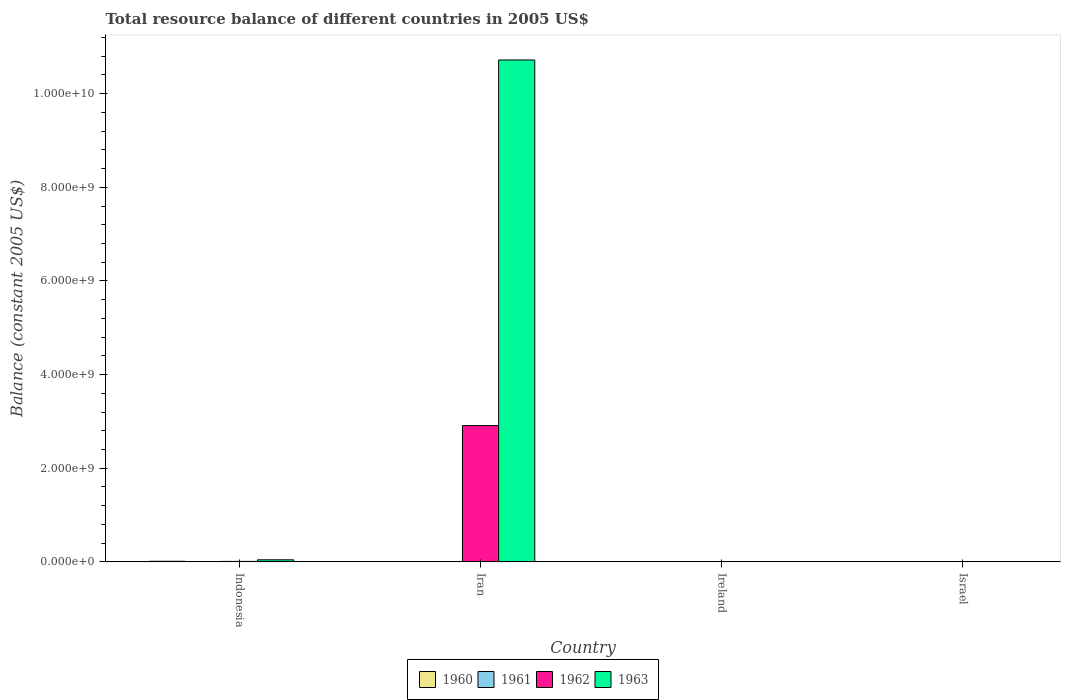Are the number of bars on each tick of the X-axis equal?
Your response must be concise. No. How many bars are there on the 4th tick from the right?
Keep it short and to the point. 3. In how many cases, is the number of bars for a given country not equal to the number of legend labels?
Provide a succinct answer. 3. What is the total resource balance in 1962 in Indonesia?
Your answer should be compact. 9.90e+06. Across all countries, what is the maximum total resource balance in 1963?
Your response must be concise. 1.07e+1. What is the total total resource balance in 1962 in the graph?
Offer a terse response. 2.92e+09. What is the difference between the total resource balance in 1962 in Iran and that in Israel?
Provide a succinct answer. 2.91e+09. What is the difference between the total resource balance in 1961 in Indonesia and the total resource balance in 1962 in Iran?
Your response must be concise. -2.91e+09. What is the average total resource balance in 1963 per country?
Keep it short and to the point. 2.69e+09. What is the difference between the total resource balance of/in 1963 and total resource balance of/in 1960 in Israel?
Ensure brevity in your answer.  1.96e+04. In how many countries, is the total resource balance in 1961 greater than 6400000000 US$?
Provide a short and direct response. 0. What is the ratio of the total resource balance in 1963 in Iran to that in Israel?
Your answer should be very brief. 4.52e+05. Is the total resource balance in 1962 in Indonesia less than that in Iran?
Make the answer very short. Yes. What is the difference between the highest and the second highest total resource balance in 1963?
Keep it short and to the point. -4.42e+07. What is the difference between the highest and the lowest total resource balance in 1962?
Ensure brevity in your answer.  2.91e+09. Is it the case that in every country, the sum of the total resource balance in 1963 and total resource balance in 1961 is greater than the sum of total resource balance in 1960 and total resource balance in 1962?
Give a very brief answer. No. Is it the case that in every country, the sum of the total resource balance in 1961 and total resource balance in 1963 is greater than the total resource balance in 1962?
Keep it short and to the point. No. Are the values on the major ticks of Y-axis written in scientific E-notation?
Your answer should be very brief. Yes. Does the graph contain grids?
Offer a terse response. No. Where does the legend appear in the graph?
Give a very brief answer. Bottom center. What is the title of the graph?
Give a very brief answer. Total resource balance of different countries in 2005 US$. What is the label or title of the X-axis?
Give a very brief answer. Country. What is the label or title of the Y-axis?
Your answer should be compact. Balance (constant 2005 US$). What is the Balance (constant 2005 US$) in 1960 in Indonesia?
Give a very brief answer. 1.30e+07. What is the Balance (constant 2005 US$) of 1962 in Indonesia?
Offer a very short reply. 9.90e+06. What is the Balance (constant 2005 US$) of 1963 in Indonesia?
Your answer should be very brief. 4.42e+07. What is the Balance (constant 2005 US$) in 1961 in Iran?
Offer a terse response. 0. What is the Balance (constant 2005 US$) of 1962 in Iran?
Ensure brevity in your answer.  2.91e+09. What is the Balance (constant 2005 US$) in 1963 in Iran?
Provide a succinct answer. 1.07e+1. What is the Balance (constant 2005 US$) in 1961 in Ireland?
Offer a terse response. 0. What is the Balance (constant 2005 US$) in 1963 in Ireland?
Make the answer very short. 0. What is the Balance (constant 2005 US$) in 1960 in Israel?
Your answer should be compact. 4100. What is the Balance (constant 2005 US$) of 1961 in Israel?
Offer a very short reply. 2000. What is the Balance (constant 2005 US$) in 1962 in Israel?
Your answer should be very brief. 8000. What is the Balance (constant 2005 US$) of 1963 in Israel?
Provide a succinct answer. 2.37e+04. Across all countries, what is the maximum Balance (constant 2005 US$) of 1960?
Your answer should be compact. 1.30e+07. Across all countries, what is the maximum Balance (constant 2005 US$) of 1962?
Ensure brevity in your answer.  2.91e+09. Across all countries, what is the maximum Balance (constant 2005 US$) in 1963?
Make the answer very short. 1.07e+1. What is the total Balance (constant 2005 US$) of 1960 in the graph?
Your answer should be very brief. 1.30e+07. What is the total Balance (constant 2005 US$) in 1961 in the graph?
Your answer should be very brief. 2000. What is the total Balance (constant 2005 US$) in 1962 in the graph?
Your answer should be compact. 2.92e+09. What is the total Balance (constant 2005 US$) of 1963 in the graph?
Your answer should be very brief. 1.08e+1. What is the difference between the Balance (constant 2005 US$) of 1962 in Indonesia and that in Iran?
Offer a very short reply. -2.90e+09. What is the difference between the Balance (constant 2005 US$) in 1963 in Indonesia and that in Iran?
Ensure brevity in your answer.  -1.07e+1. What is the difference between the Balance (constant 2005 US$) of 1960 in Indonesia and that in Israel?
Make the answer very short. 1.30e+07. What is the difference between the Balance (constant 2005 US$) of 1962 in Indonesia and that in Israel?
Offer a terse response. 9.90e+06. What is the difference between the Balance (constant 2005 US$) in 1963 in Indonesia and that in Israel?
Ensure brevity in your answer.  4.42e+07. What is the difference between the Balance (constant 2005 US$) in 1962 in Iran and that in Israel?
Keep it short and to the point. 2.91e+09. What is the difference between the Balance (constant 2005 US$) of 1963 in Iran and that in Israel?
Your response must be concise. 1.07e+1. What is the difference between the Balance (constant 2005 US$) of 1960 in Indonesia and the Balance (constant 2005 US$) of 1962 in Iran?
Your answer should be very brief. -2.90e+09. What is the difference between the Balance (constant 2005 US$) in 1960 in Indonesia and the Balance (constant 2005 US$) in 1963 in Iran?
Ensure brevity in your answer.  -1.07e+1. What is the difference between the Balance (constant 2005 US$) of 1962 in Indonesia and the Balance (constant 2005 US$) of 1963 in Iran?
Provide a succinct answer. -1.07e+1. What is the difference between the Balance (constant 2005 US$) of 1960 in Indonesia and the Balance (constant 2005 US$) of 1961 in Israel?
Give a very brief answer. 1.30e+07. What is the difference between the Balance (constant 2005 US$) of 1960 in Indonesia and the Balance (constant 2005 US$) of 1962 in Israel?
Provide a succinct answer. 1.30e+07. What is the difference between the Balance (constant 2005 US$) in 1960 in Indonesia and the Balance (constant 2005 US$) in 1963 in Israel?
Offer a very short reply. 1.30e+07. What is the difference between the Balance (constant 2005 US$) in 1962 in Indonesia and the Balance (constant 2005 US$) in 1963 in Israel?
Your answer should be very brief. 9.88e+06. What is the difference between the Balance (constant 2005 US$) in 1962 in Iran and the Balance (constant 2005 US$) in 1963 in Israel?
Make the answer very short. 2.91e+09. What is the average Balance (constant 2005 US$) of 1960 per country?
Give a very brief answer. 3.25e+06. What is the average Balance (constant 2005 US$) of 1962 per country?
Your answer should be very brief. 7.30e+08. What is the average Balance (constant 2005 US$) of 1963 per country?
Offer a very short reply. 2.69e+09. What is the difference between the Balance (constant 2005 US$) in 1960 and Balance (constant 2005 US$) in 1962 in Indonesia?
Offer a very short reply. 3.08e+06. What is the difference between the Balance (constant 2005 US$) of 1960 and Balance (constant 2005 US$) of 1963 in Indonesia?
Your response must be concise. -3.12e+07. What is the difference between the Balance (constant 2005 US$) in 1962 and Balance (constant 2005 US$) in 1963 in Indonesia?
Offer a very short reply. -3.43e+07. What is the difference between the Balance (constant 2005 US$) of 1962 and Balance (constant 2005 US$) of 1963 in Iran?
Offer a terse response. -7.81e+09. What is the difference between the Balance (constant 2005 US$) in 1960 and Balance (constant 2005 US$) in 1961 in Israel?
Provide a short and direct response. 2100. What is the difference between the Balance (constant 2005 US$) in 1960 and Balance (constant 2005 US$) in 1962 in Israel?
Your answer should be very brief. -3900. What is the difference between the Balance (constant 2005 US$) in 1960 and Balance (constant 2005 US$) in 1963 in Israel?
Provide a short and direct response. -1.96e+04. What is the difference between the Balance (constant 2005 US$) of 1961 and Balance (constant 2005 US$) of 1962 in Israel?
Your response must be concise. -6000. What is the difference between the Balance (constant 2005 US$) in 1961 and Balance (constant 2005 US$) in 1963 in Israel?
Your answer should be compact. -2.17e+04. What is the difference between the Balance (constant 2005 US$) in 1962 and Balance (constant 2005 US$) in 1963 in Israel?
Your response must be concise. -1.57e+04. What is the ratio of the Balance (constant 2005 US$) of 1962 in Indonesia to that in Iran?
Your response must be concise. 0. What is the ratio of the Balance (constant 2005 US$) in 1963 in Indonesia to that in Iran?
Ensure brevity in your answer.  0. What is the ratio of the Balance (constant 2005 US$) of 1960 in Indonesia to that in Israel?
Give a very brief answer. 3166.17. What is the ratio of the Balance (constant 2005 US$) in 1962 in Indonesia to that in Israel?
Provide a short and direct response. 1237.97. What is the ratio of the Balance (constant 2005 US$) of 1963 in Indonesia to that in Israel?
Provide a short and direct response. 1865.71. What is the ratio of the Balance (constant 2005 US$) in 1962 in Iran to that in Israel?
Your answer should be compact. 3.64e+05. What is the ratio of the Balance (constant 2005 US$) of 1963 in Iran to that in Israel?
Make the answer very short. 4.52e+05. What is the difference between the highest and the second highest Balance (constant 2005 US$) of 1962?
Your answer should be very brief. 2.90e+09. What is the difference between the highest and the second highest Balance (constant 2005 US$) of 1963?
Keep it short and to the point. 1.07e+1. What is the difference between the highest and the lowest Balance (constant 2005 US$) in 1960?
Your answer should be compact. 1.30e+07. What is the difference between the highest and the lowest Balance (constant 2005 US$) in 1961?
Offer a very short reply. 2000. What is the difference between the highest and the lowest Balance (constant 2005 US$) in 1962?
Provide a short and direct response. 2.91e+09. What is the difference between the highest and the lowest Balance (constant 2005 US$) of 1963?
Your answer should be very brief. 1.07e+1. 